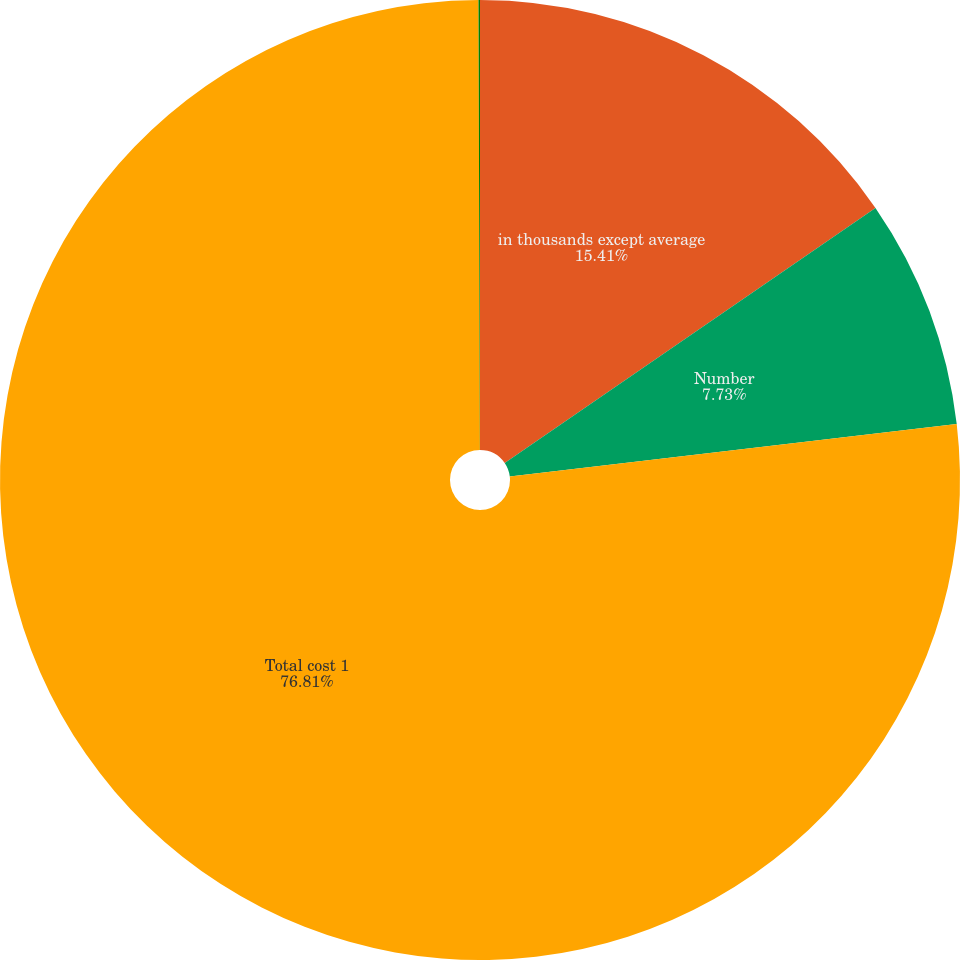Convert chart. <chart><loc_0><loc_0><loc_500><loc_500><pie_chart><fcel>in thousands except average<fcel>Number<fcel>Total cost 1<fcel>Average cost 1 g<nl><fcel>15.41%<fcel>7.73%<fcel>76.81%<fcel>0.05%<nl></chart> 